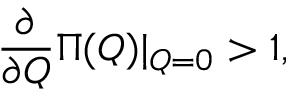<formula> <loc_0><loc_0><loc_500><loc_500>\frac { \partial } { \partial Q } \Pi ( Q ) | _ { Q = 0 } > 1 ,</formula> 